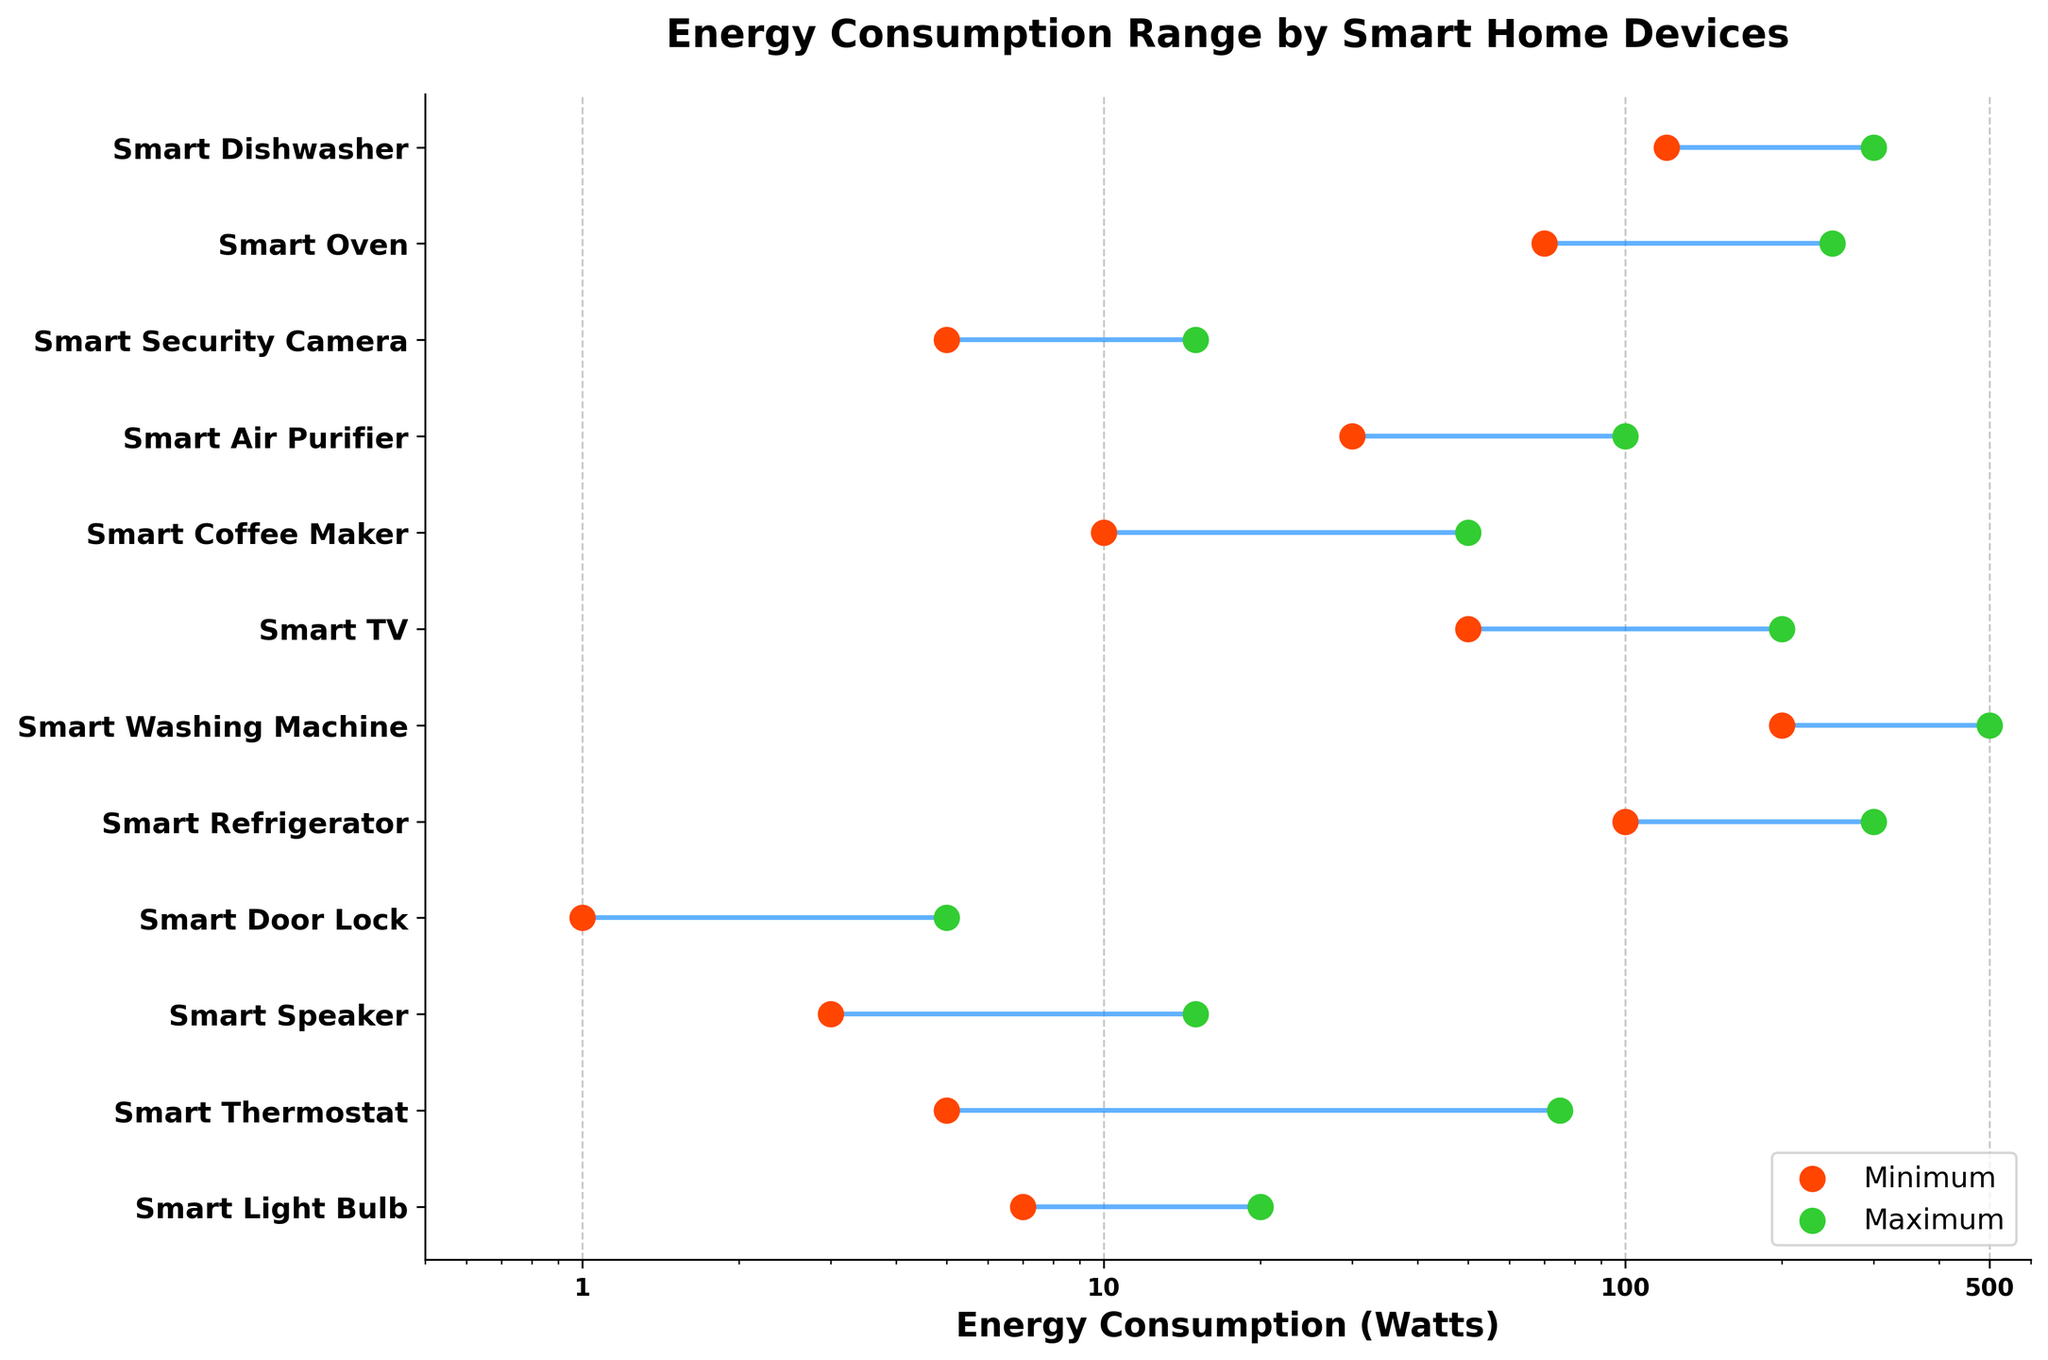How many smart home devices are shown in the plot? Count the number of devices listed on the y-axis. There are 12 devices displayed in the plot.
Answer: 12 Which smart home device has the lowest possible energy consumption? Compare the minimum energy consumption values for each device. The Smart Door Lock has the lowest minimum energy consumption at 1 watt.
Answer: Smart Door Lock What is the energy consumption range for the Smart Washing Machine? Look for the min and max values for the Smart Washing Machine. The range is from 200 watts to 500 watts.
Answer: 200-500 watts What device has the widest range of energy consumption? Determine the difference between the minimum and maximum values for each device and identify the largest range. The Smart Washing Machine has the widest range of 300 watts (500 - 200).
Answer: Smart Washing Machine Are there any devices with the same maximum energy consumption? If yes, which ones? Compare the maximum energy values for all devices and find any that match. Both the Smart Refrigerator and Smart Dishwasher have a maximum energy consumption of 300 watts.
Answer: Smart Refrigerator and Smart Dishwasher Which device has a higher minimum energy consumption, the Smart Light Bulb or the Smart TV? Compare the minimum energy consumptions of the Smart Light Bulb (7 watts) and the Smart TV (50 watts). The Smart TV has a higher minimum energy consumption.
Answer: Smart TV What is the average maximum energy consumption of all the devices? Sum all the maximum energy consumption values and divide by the number of devices. The sum of maximum values is 1830, and dividing by 12 gives approximately 152.5 watts.
Answer: ~152.5 watts Which device has a lower energy consumption range, the Smart Security Camera or the Smart Speaker? Calculate the range for the Smart Security Camera (10 watts, from 5 to 15) and the Smart Speaker (12 watts, from 3 to 15). The Smart Security Camera has a lower range.
Answer: Smart Security Camera What is the total energy consumption range for the Smart Air Purifier compared to the Smart Coffee Maker? Check the min and max values for both devices (30-100 for Air Purifier, 10-50 for Coffee Maker). The range for the Air Purifier is 70 watts (100 - 30) and for the Coffee Maker, it's 40 watts (50 - 10).
Answer: 70 watts (Air Purifier), 40 watts (Coffee Maker) What is the sum of the minimum energy consumption values for all devices? Sum all the minimum energy consumption values listed. The sum is 601 watts.
Answer: 601 watts 